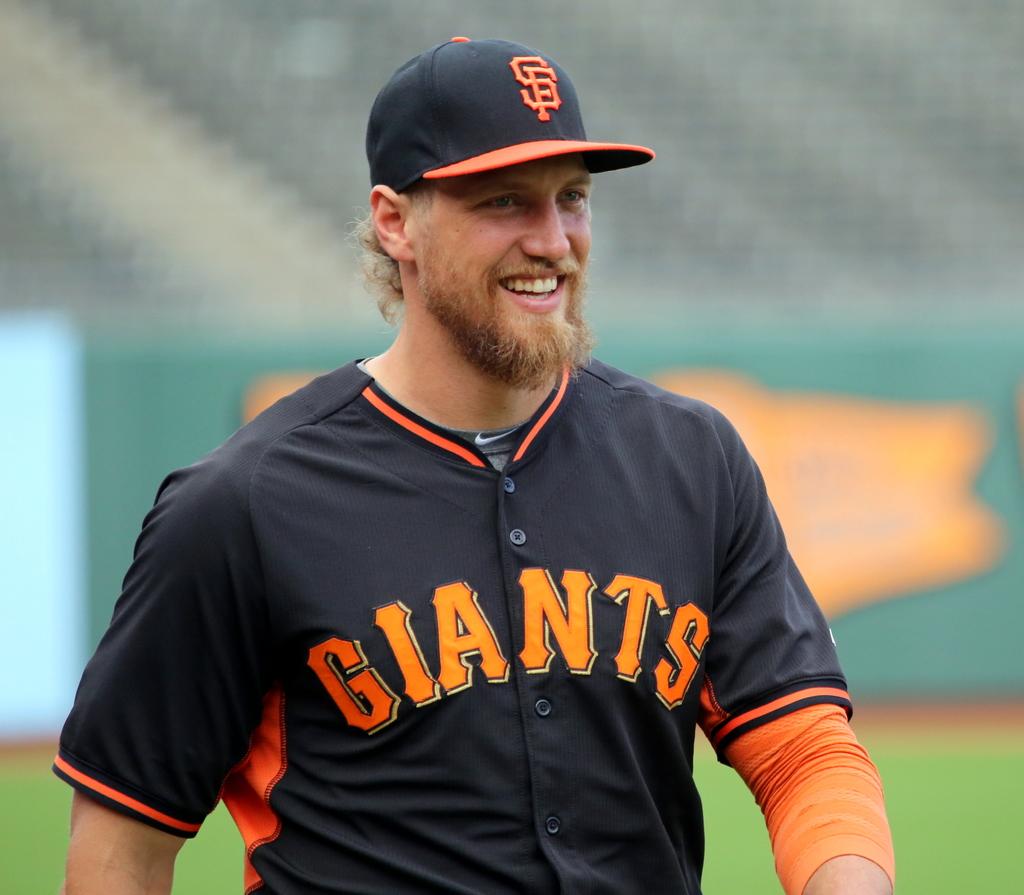What team does the baseball player play for?
Offer a terse response. Giants. 